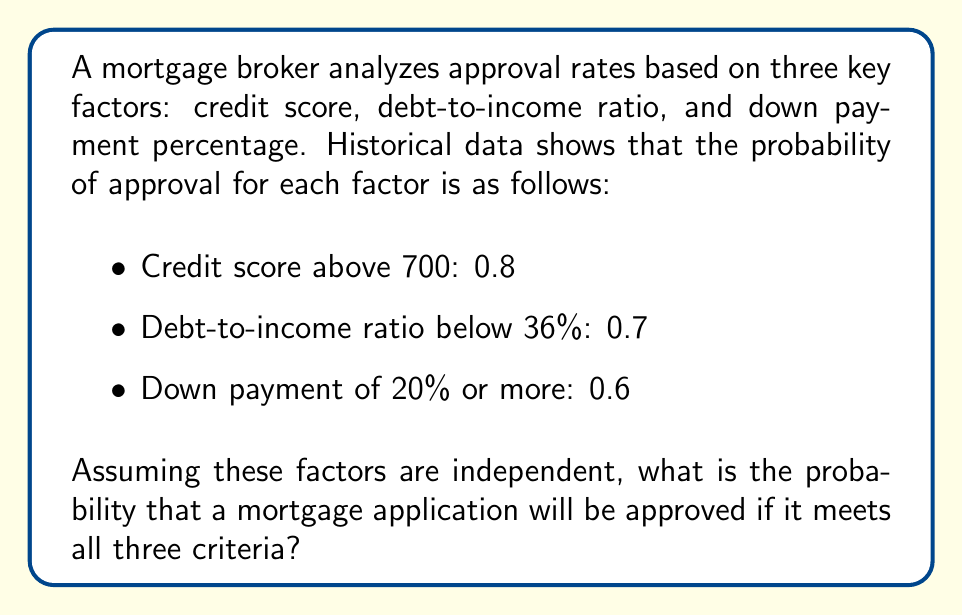Give your solution to this math problem. To solve this problem, we need to use the concept of independent events in probability theory. When events are independent, the probability of all events occurring simultaneously is the product of their individual probabilities.

Let's define our events:
A: Credit score above 700
B: Debt-to-income ratio below 36%
C: Down payment of 20% or more

We are given:
P(A) = 0.8
P(B) = 0.7
P(C) = 0.6

We want to find P(A ∩ B ∩ C), the probability of all three events occurring together.

For independent events:

$$ P(A \cap B \cap C) = P(A) \cdot P(B) \cdot P(C) $$

Substituting the given probabilities:

$$ P(A \cap B \cap C) = 0.8 \cdot 0.7 \cdot 0.6 $$

Calculating:

$$ P(A \cap B \cap C) = 0.336 $$

Therefore, the probability of a mortgage application being approved if it meets all three criteria is 0.336 or 33.6%.
Answer: 0.336 or 33.6% 